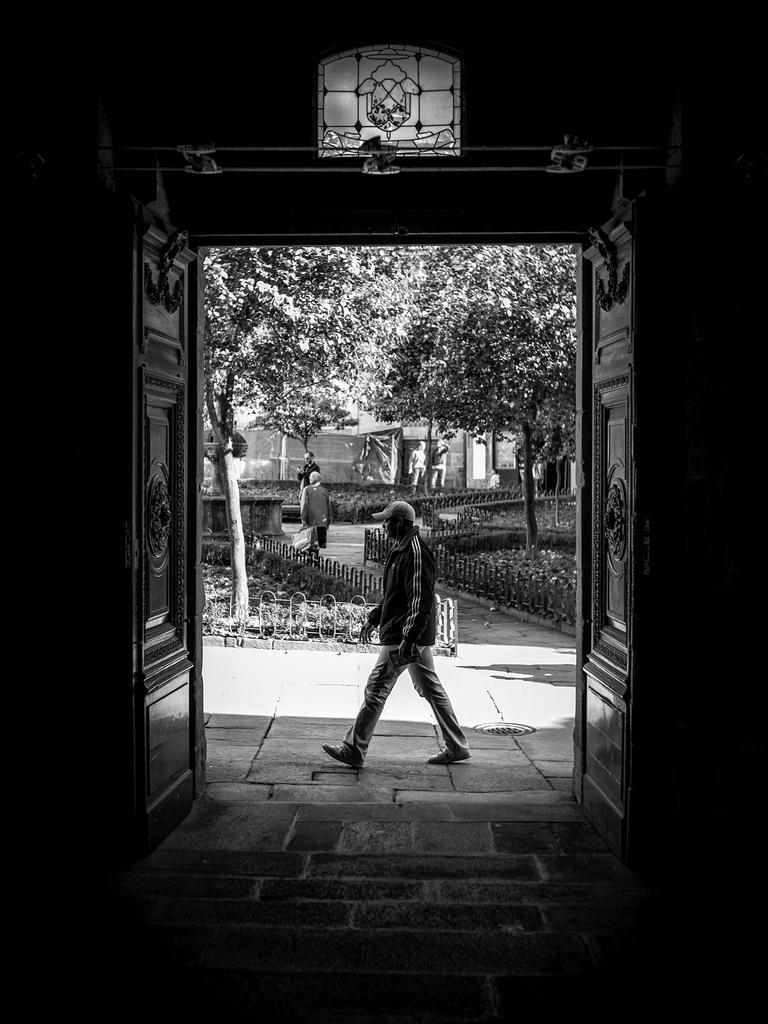Could you give a brief overview of what you see in this image? In this image, we can see the doors, there is a person walking. We can see the fence, there are some trees. 